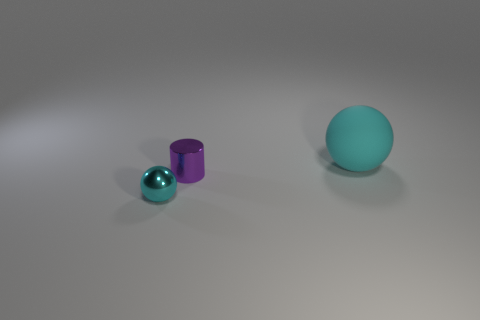Add 3 cyan metallic balls. How many objects exist? 6 Subtract all cylinders. How many objects are left? 2 Add 2 tiny metallic objects. How many tiny metallic objects are left? 4 Add 2 big blue metallic cylinders. How many big blue metallic cylinders exist? 2 Subtract 0 red blocks. How many objects are left? 3 Subtract all yellow spheres. Subtract all yellow cubes. How many spheres are left? 2 Subtract all tiny balls. Subtract all purple metallic cylinders. How many objects are left? 1 